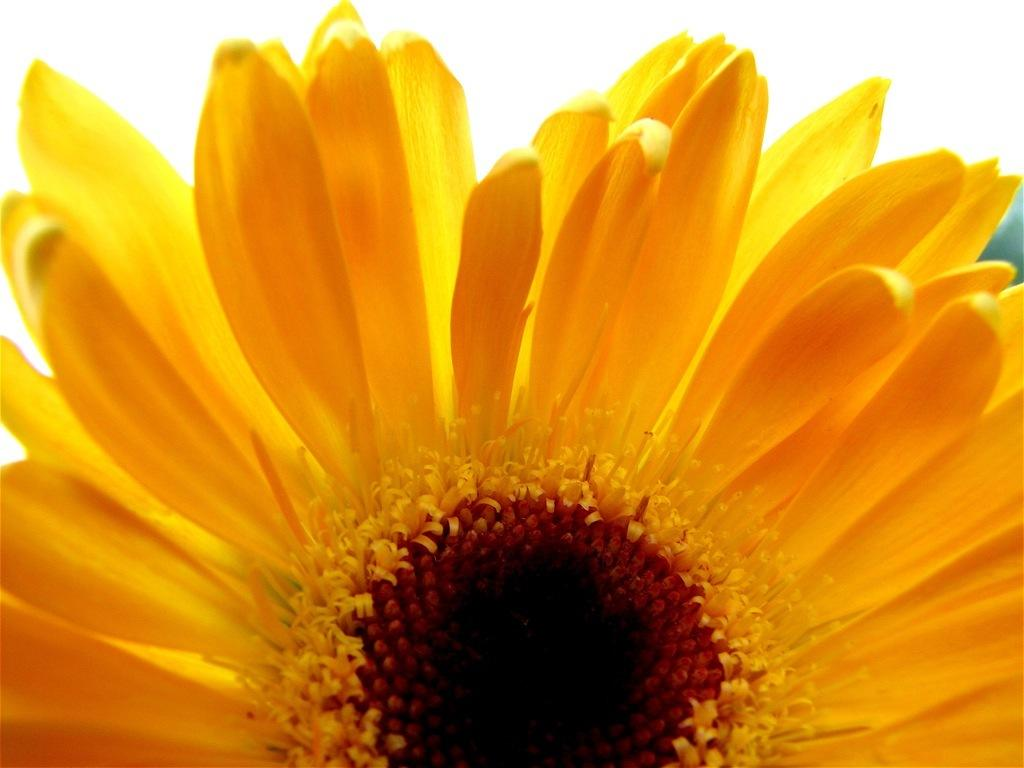What type of plant is featured in the image? There is a sunflower in the image. Can you see any cracks in the ocean in the image? There is no ocean present in the image, as it features a sunflower. What unit of measurement is used to determine the height of the sunflower in the image? The provided facts do not mention any unit of measurement for the sunflower's height, and there is no need to measure it in the image. 